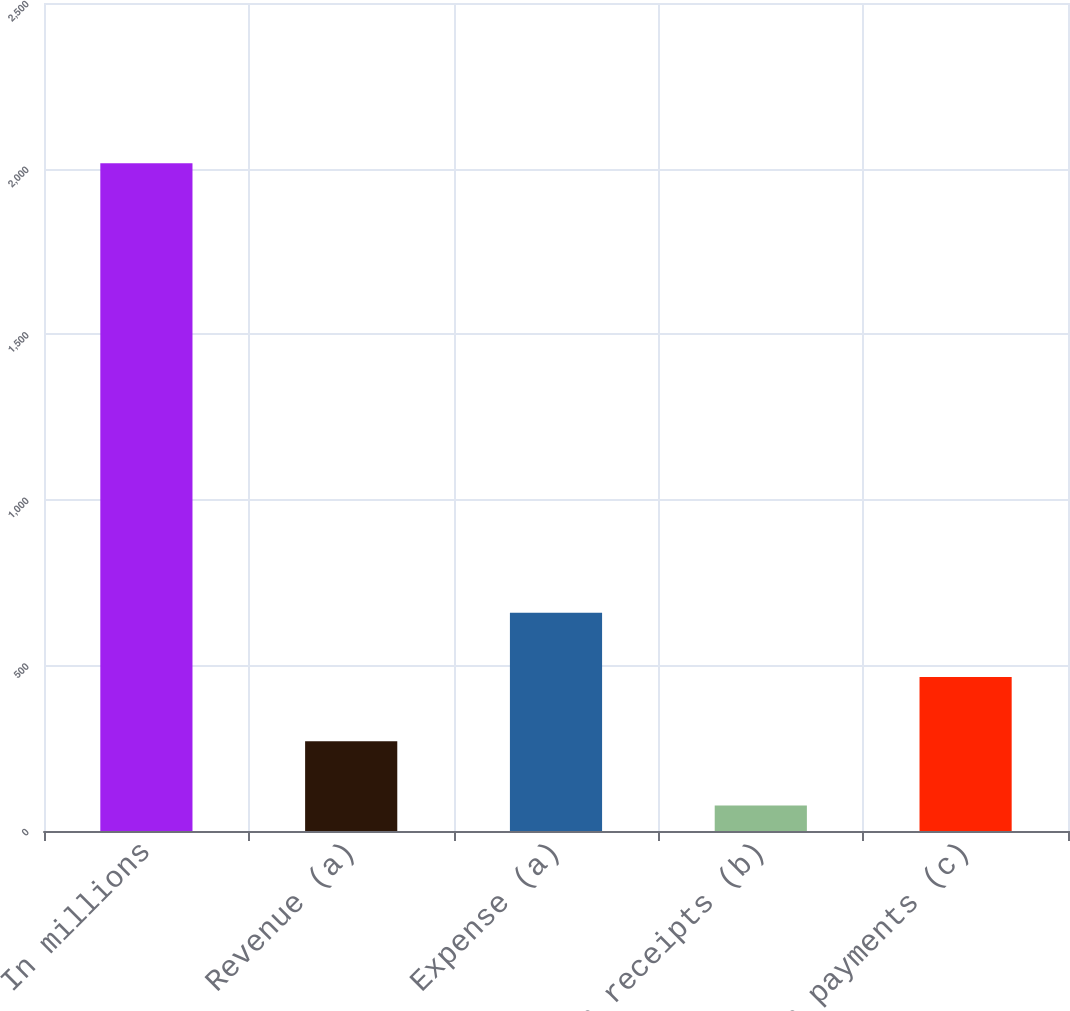Convert chart. <chart><loc_0><loc_0><loc_500><loc_500><bar_chart><fcel>In millions<fcel>Revenue (a)<fcel>Expense (a)<fcel>Cash receipts (b)<fcel>Cash payments (c)<nl><fcel>2016<fcel>270.9<fcel>658.7<fcel>77<fcel>464.8<nl></chart> 